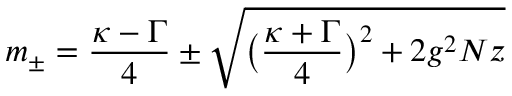<formula> <loc_0><loc_0><loc_500><loc_500>m _ { \pm } = \frac { \kappa - \Gamma } { 4 } \pm \sqrt { \left ( \frac { \kappa + \Gamma } { 4 } \right ) ^ { 2 } + 2 g ^ { 2 } N z }</formula> 